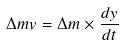Convert formula to latex. <formula><loc_0><loc_0><loc_500><loc_500>\Delta m v = \Delta m \times \frac { d y } { d t }</formula> 